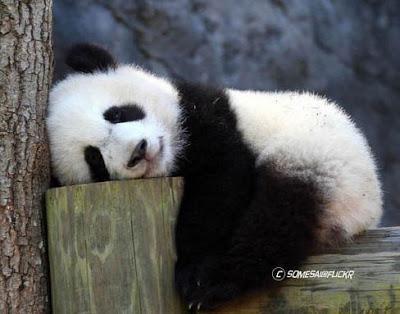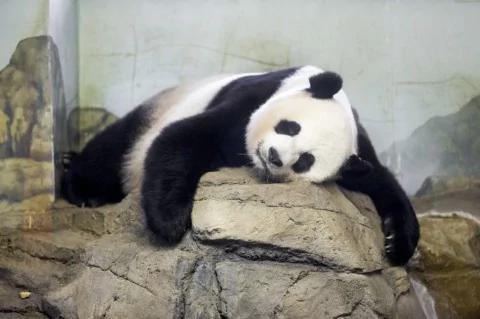The first image is the image on the left, the second image is the image on the right. Given the left and right images, does the statement "One of the pandas is lounging on a large rock." hold true? Answer yes or no. Yes. 